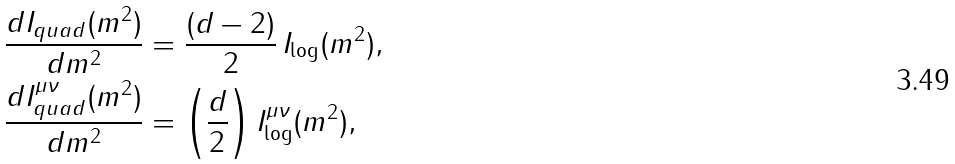Convert formula to latex. <formula><loc_0><loc_0><loc_500><loc_500>\frac { d I _ { q u a d } ( m ^ { 2 } ) } { d m ^ { 2 } } & = \frac { ( d - 2 ) } { 2 } \, I _ { \log } ( m ^ { 2 } ) , \\ \frac { d I _ { q u a d } ^ { \mu \nu } ( m ^ { 2 } ) } { d m ^ { 2 } } & = \left ( \frac { d } { 2 } \right ) I _ { \log } ^ { \mu \nu } ( m ^ { 2 } ) ,</formula> 